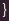<code> <loc_0><loc_0><loc_500><loc_500><_Java_>
}
</code> 